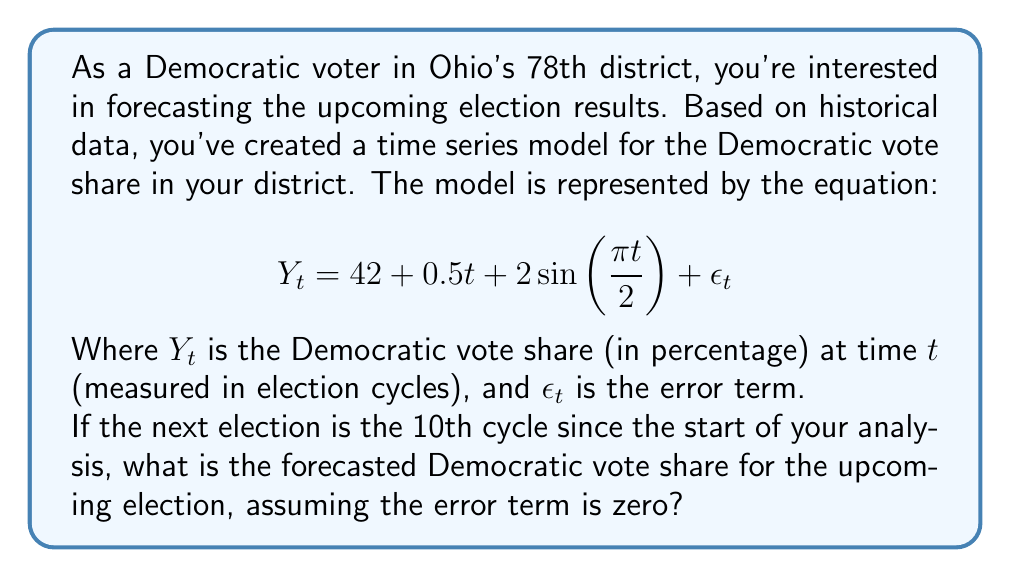Help me with this question. To solve this problem, we need to follow these steps:

1) Identify the components of the time series model:
   - Intercept: 42
   - Linear trend: $0.5t$
   - Cyclical component: $2\sin(\frac{\pi t}{2})$
   - Error term: $\epsilon_t$ (assumed to be zero for this forecast)

2) Substitute $t = 10$ into the equation:

   $$Y_{10} = 42 + 0.5(10) + 2\sin(\frac{\pi 10}{2}) + 0$$

3) Calculate the linear trend component:
   $0.5(10) = 5$

4) Calculate the cyclical component:
   $2\sin(\frac{\pi 10}{2}) = 2\sin(5\pi) = 0$
   (Note: $\sin(5\pi) = 0$ because sine has a period of $2\pi$)

5) Sum up all components:
   $Y_{10} = 42 + 5 + 0 + 0 = 47$

Therefore, the forecasted Democratic vote share for the 10th election cycle is 47%.
Answer: 47% 